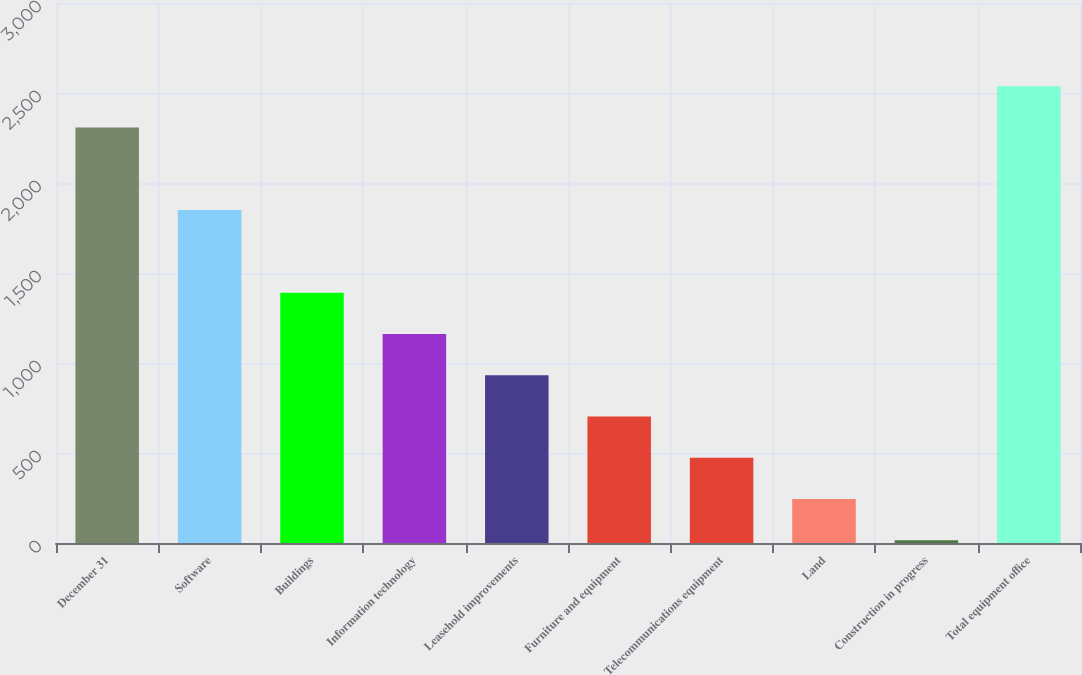Convert chart to OTSL. <chart><loc_0><loc_0><loc_500><loc_500><bar_chart><fcel>December 31<fcel>Software<fcel>Buildings<fcel>Information technology<fcel>Leasehold improvements<fcel>Furniture and equipment<fcel>Telecommunications equipment<fcel>Land<fcel>Construction in progress<fcel>Total equipment office<nl><fcel>2308<fcel>1849.4<fcel>1390.8<fcel>1161.5<fcel>932.2<fcel>702.9<fcel>473.6<fcel>244.3<fcel>15<fcel>2537.3<nl></chart> 